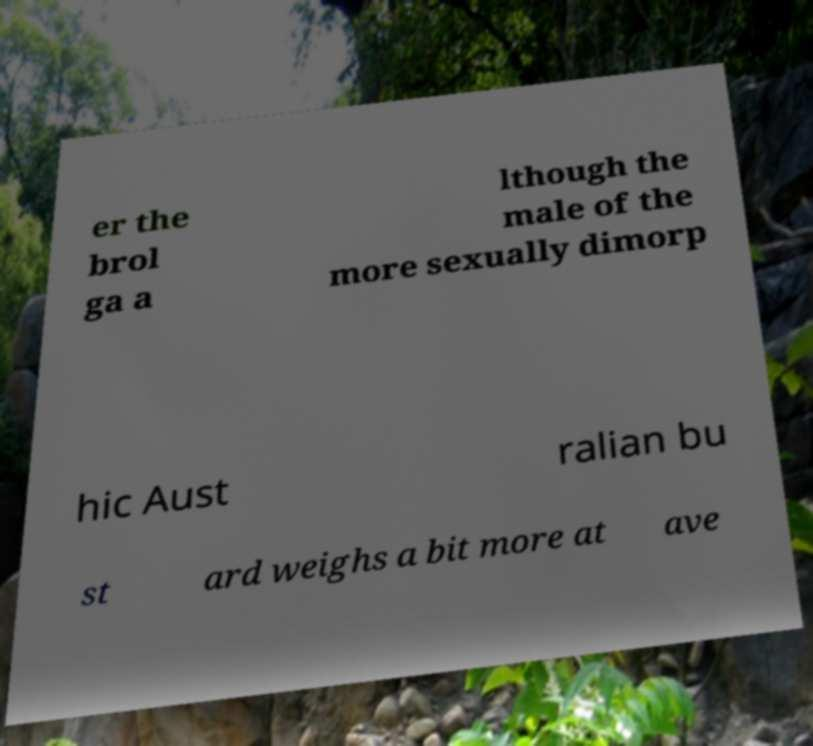Could you extract and type out the text from this image? er the brol ga a lthough the male of the more sexually dimorp hic Aust ralian bu st ard weighs a bit more at ave 